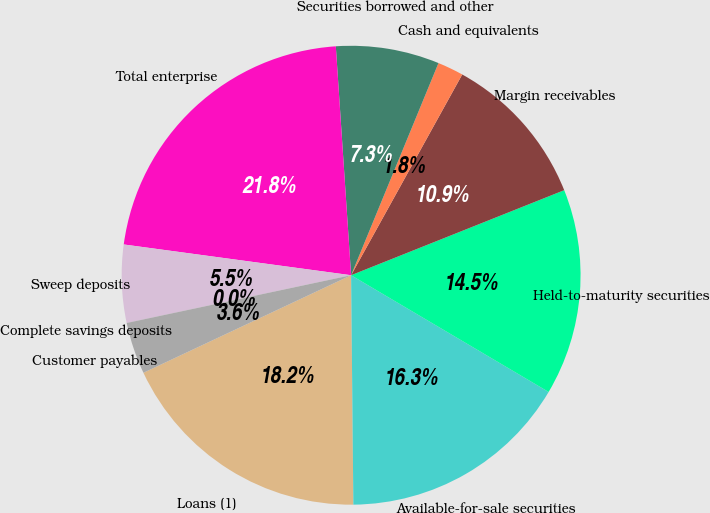Convert chart. <chart><loc_0><loc_0><loc_500><loc_500><pie_chart><fcel>Loans (1)<fcel>Available-for-sale securities<fcel>Held-to-maturity securities<fcel>Margin receivables<fcel>Cash and equivalents<fcel>Securities borrowed and other<fcel>Total enterprise<fcel>Sweep deposits<fcel>Complete savings deposits<fcel>Customer payables<nl><fcel>18.17%<fcel>16.35%<fcel>14.54%<fcel>10.91%<fcel>1.83%<fcel>7.28%<fcel>21.8%<fcel>5.46%<fcel>0.02%<fcel>3.65%<nl></chart> 